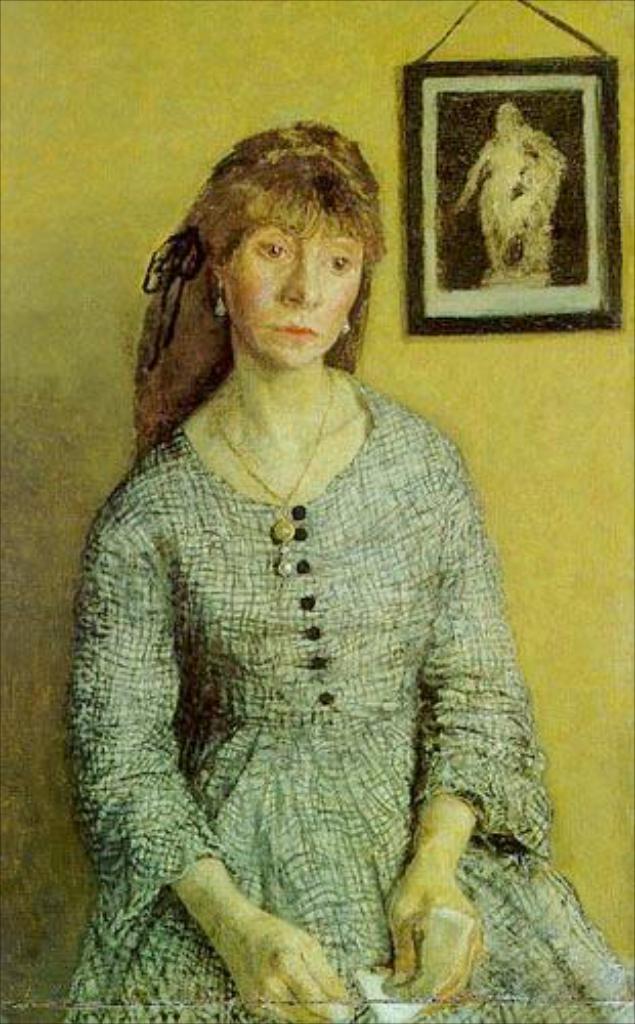Please provide a concise description of this image. This is a painted image, where there is a woman sitting near a wall and a photo frame is on the wall. 